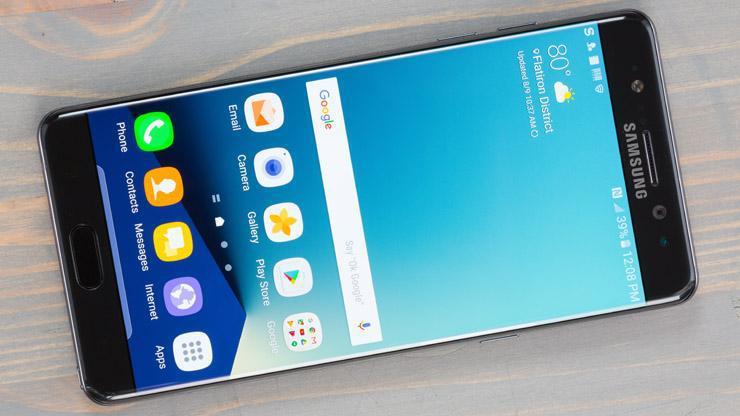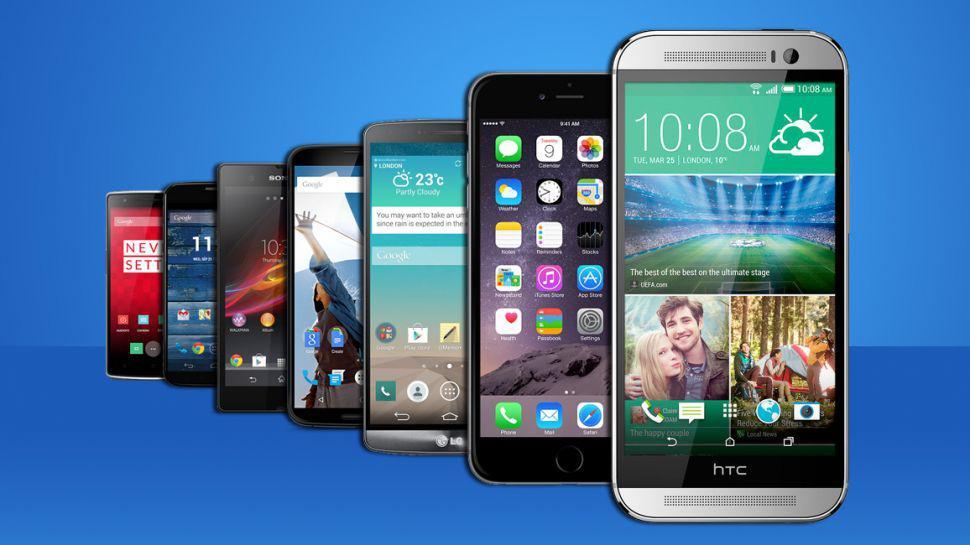The first image is the image on the left, the second image is the image on the right. Considering the images on both sides, is "The back of a phone is visible." valid? Answer yes or no. No. The first image is the image on the left, the second image is the image on the right. Examine the images to the left and right. Is the description "The image on the left shows one smartphone, face up on a wood table." accurate? Answer yes or no. Yes. 